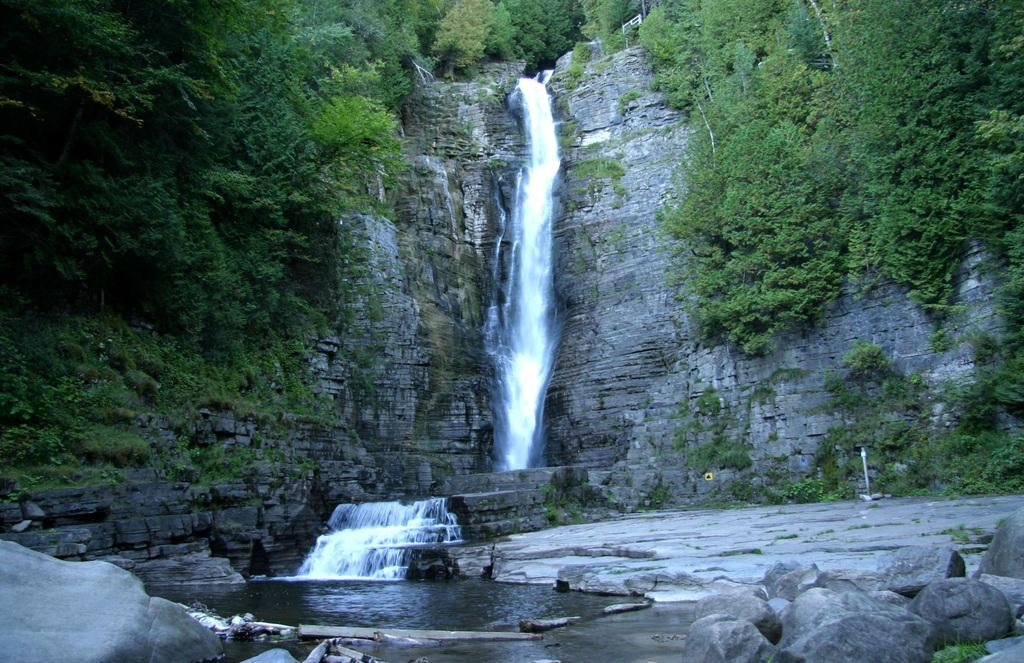What can be seen in the foreground of the picture? In the foreground of the picture, there are rocks, plants, wooden logs, and water visible. What is located at the top of the picture? At the top of the picture, there are trees, plants, a hill, and a waterfall. Can you see a glove being used to catch a baseball in the image? There is no glove or baseball present in the image. Is there a spring visible in the image? There is no spring visible in the image. 